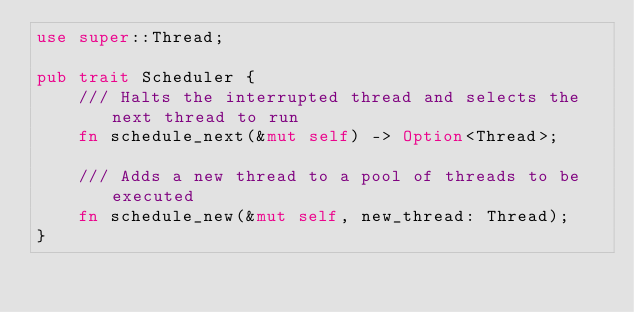<code> <loc_0><loc_0><loc_500><loc_500><_Rust_>use super::Thread;

pub trait Scheduler {
	/// Halts the interrupted thread and selects the next thread to run
	fn schedule_next(&mut self) -> Option<Thread>;

	/// Adds a new thread to a pool of threads to be executed
	fn schedule_new(&mut self, new_thread: Thread);
}
</code> 